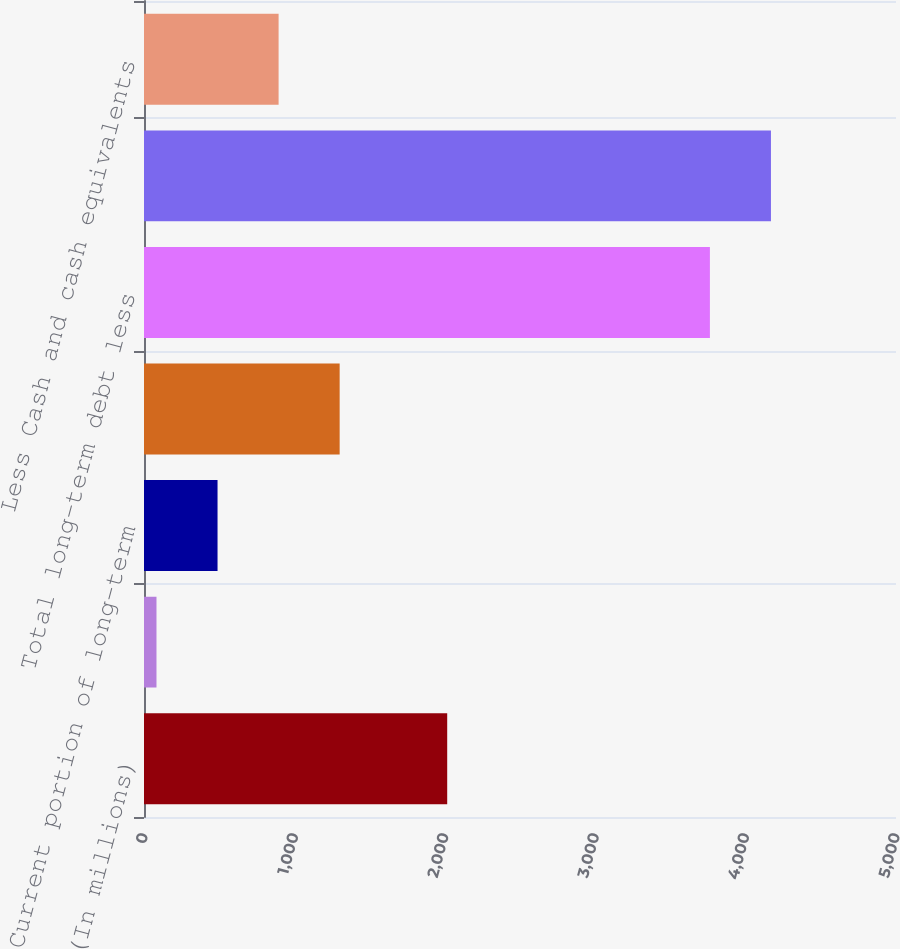Convert chart. <chart><loc_0><loc_0><loc_500><loc_500><bar_chart><fcel>(In millions)<fcel>Short-term borrowings<fcel>Current portion of long-term<fcel>Total current debt<fcel>Total long-term debt less<fcel>Total debt<fcel>Less Cash and cash equivalents<nl><fcel>2016<fcel>83<fcel>488.96<fcel>1300.88<fcel>3762.6<fcel>4168.56<fcel>894.92<nl></chart> 